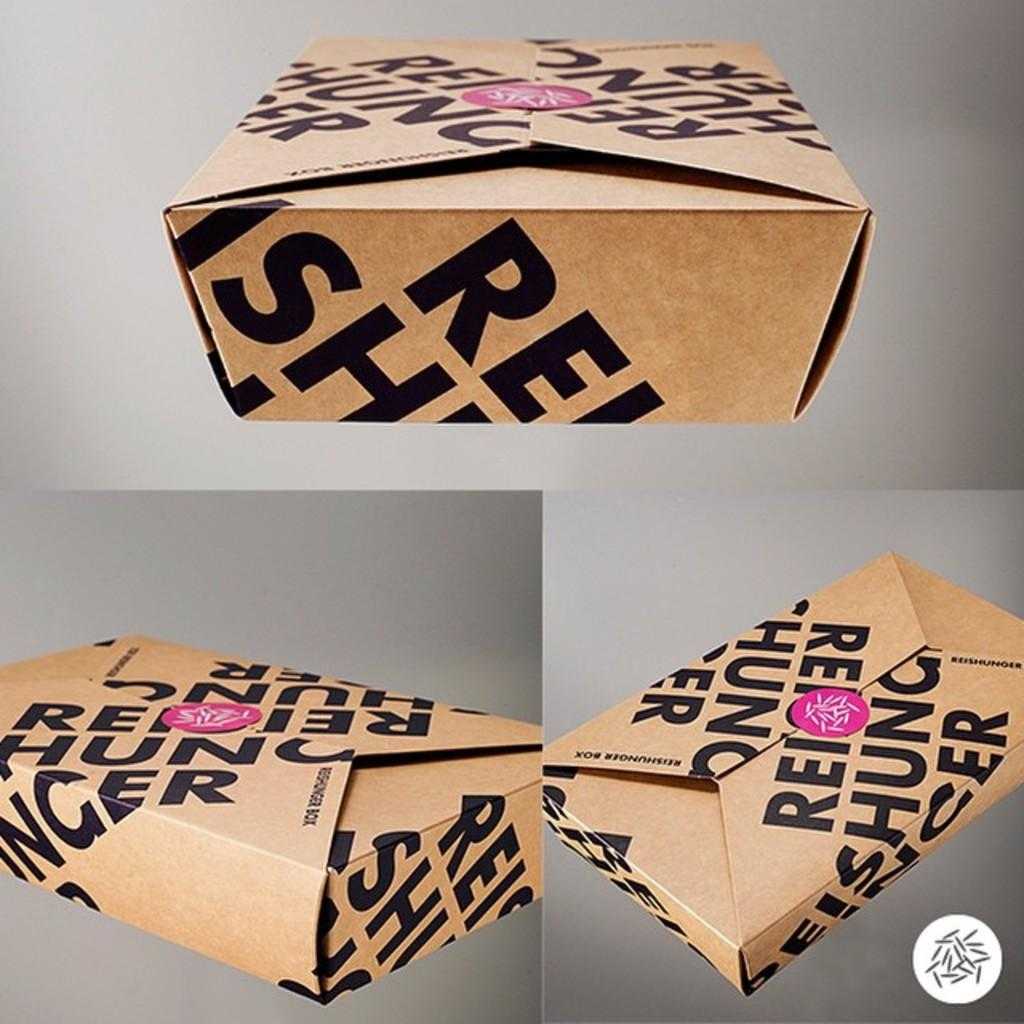<image>
Create a compact narrative representing the image presented. A box has a pink sticker on it and is labelled Reischung. 